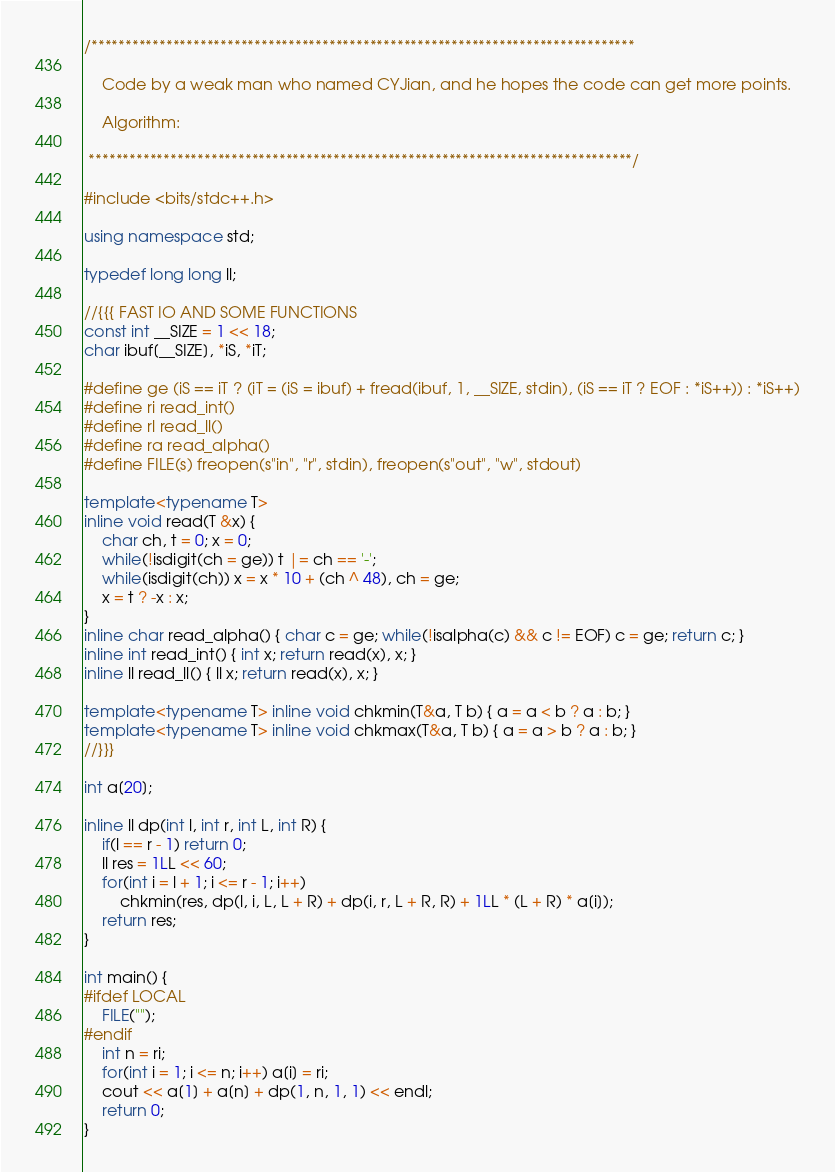Convert code to text. <code><loc_0><loc_0><loc_500><loc_500><_C++_>/********************************************************************************
	
	Code by a weak man who named CYJian, and he hopes the code can get more points.

	Algorithm: 

 ********************************************************************************/

#include <bits/stdc++.h>

using namespace std;

typedef long long ll;

//{{{ FAST IO AND SOME FUNCTIONS
const int __SIZE = 1 << 18;
char ibuf[__SIZE], *iS, *iT;

#define ge (iS == iT ? (iT = (iS = ibuf) + fread(ibuf, 1, __SIZE, stdin), (iS == iT ? EOF : *iS++)) : *iS++)
#define ri read_int()
#define rl read_ll()
#define ra read_alpha()
#define FILE(s) freopen(s"in", "r", stdin), freopen(s"out", "w", stdout)

template<typename T>
inline void read(T &x) {
	char ch, t = 0; x = 0;
	while(!isdigit(ch = ge)) t |= ch == '-';
	while(isdigit(ch)) x = x * 10 + (ch ^ 48), ch = ge;
	x = t ? -x : x;
}
inline char read_alpha() { char c = ge; while(!isalpha(c) && c != EOF) c = ge; return c; }
inline int read_int() { int x; return read(x), x; }
inline ll read_ll() { ll x; return read(x), x; }

template<typename T> inline void chkmin(T&a, T b) { a = a < b ? a : b; }
template<typename T> inline void chkmax(T&a, T b) { a = a > b ? a : b; }
//}}}

int a[20];

inline ll dp(int l, int r, int L, int R) {
	if(l == r - 1) return 0;
	ll res = 1LL << 60;
	for(int i = l + 1; i <= r - 1; i++)
		chkmin(res, dp(l, i, L, L + R) + dp(i, r, L + R, R) + 1LL * (L + R) * a[i]);
	return res;
}

int main() {
#ifdef LOCAL
	FILE("");
#endif
	int n = ri;
	for(int i = 1; i <= n; i++) a[i] = ri;
	cout << a[1] + a[n] + dp(1, n, 1, 1) << endl;
	return 0;
}</code> 